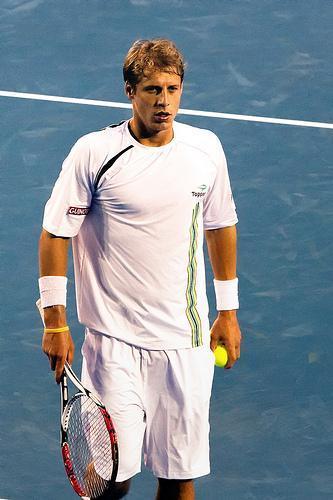How many balls are there?
Give a very brief answer. 1. 